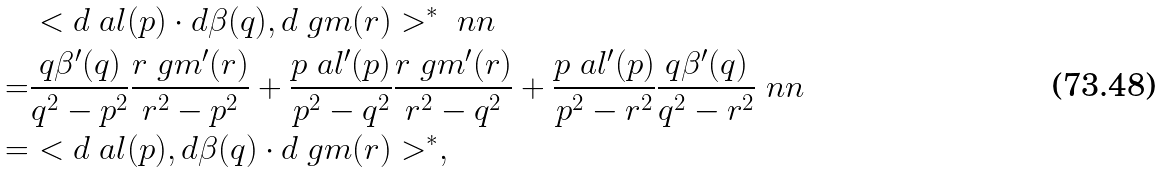Convert formula to latex. <formula><loc_0><loc_0><loc_500><loc_500>& < d \ a l ( p ) \cdot d \beta ( q ) , d \ g m ( r ) > ^ { * } \ n n \\ = & \frac { q \beta ^ { \prime } ( q ) } { q ^ { 2 } - p ^ { 2 } } \frac { r \ g m ^ { \prime } ( r ) } { r ^ { 2 } - p ^ { 2 } } + \frac { p \ a l ^ { \prime } ( p ) } { p ^ { 2 } - q ^ { 2 } } \frac { r \ g m ^ { \prime } ( r ) } { r ^ { 2 } - q ^ { 2 } } + \frac { p \ a l ^ { \prime } ( p ) } { p ^ { 2 } - r ^ { 2 } } \frac { q \beta ^ { \prime } ( q ) } { q ^ { 2 } - r ^ { 2 } } \ n n \\ = & < d \ a l ( p ) , d \beta ( q ) \cdot d \ g m ( r ) > ^ { * } ,</formula> 